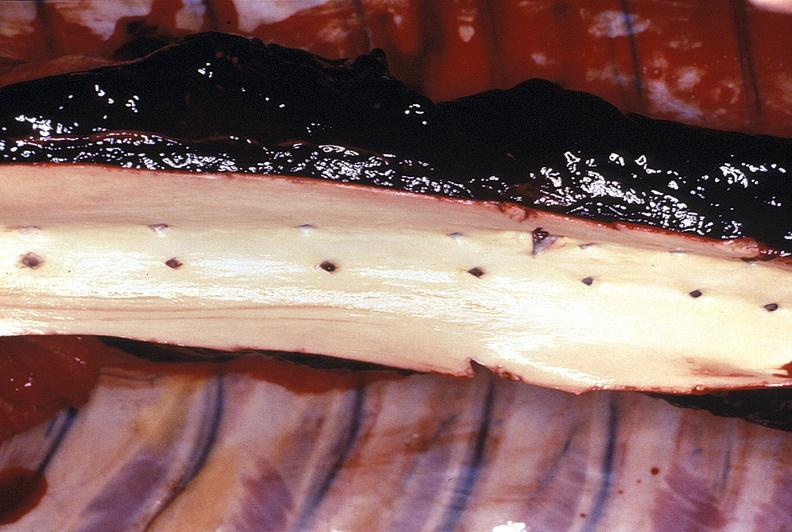what does this image show?
Answer the question using a single word or phrase. Aorta 